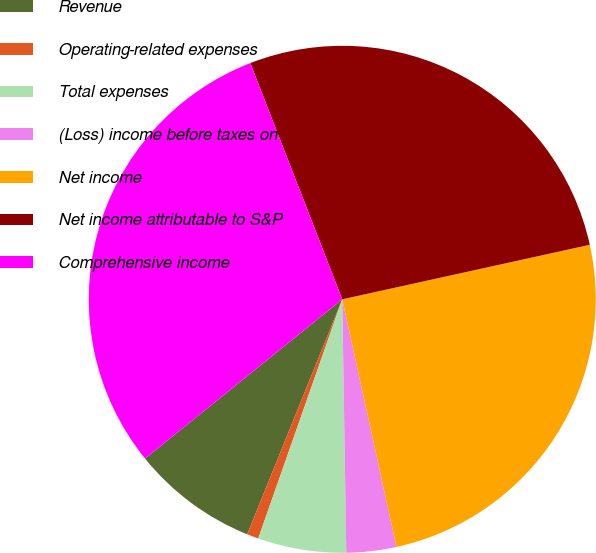Convert chart to OTSL. <chart><loc_0><loc_0><loc_500><loc_500><pie_chart><fcel>Revenue<fcel>Operating-related expenses<fcel>Total expenses<fcel>(Loss) income before taxes on<fcel>Net income<fcel>Net income attributable to S&P<fcel>Comprehensive income<nl><fcel>8.07%<fcel>0.74%<fcel>5.63%<fcel>3.18%<fcel>25.02%<fcel>27.46%<fcel>29.91%<nl></chart> 